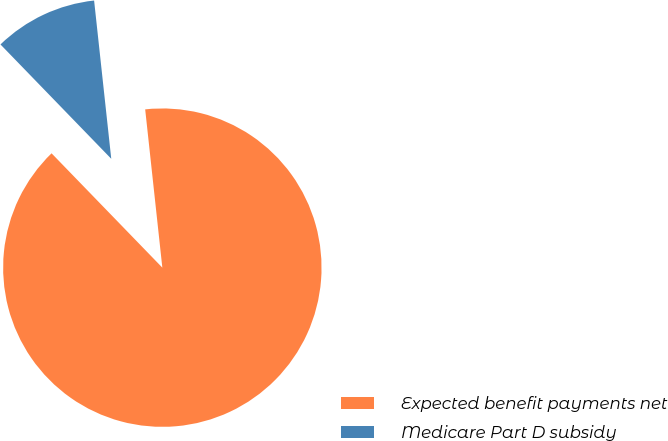Convert chart to OTSL. <chart><loc_0><loc_0><loc_500><loc_500><pie_chart><fcel>Expected benefit payments net<fcel>Medicare Part D subsidy<nl><fcel>89.47%<fcel>10.53%<nl></chart> 